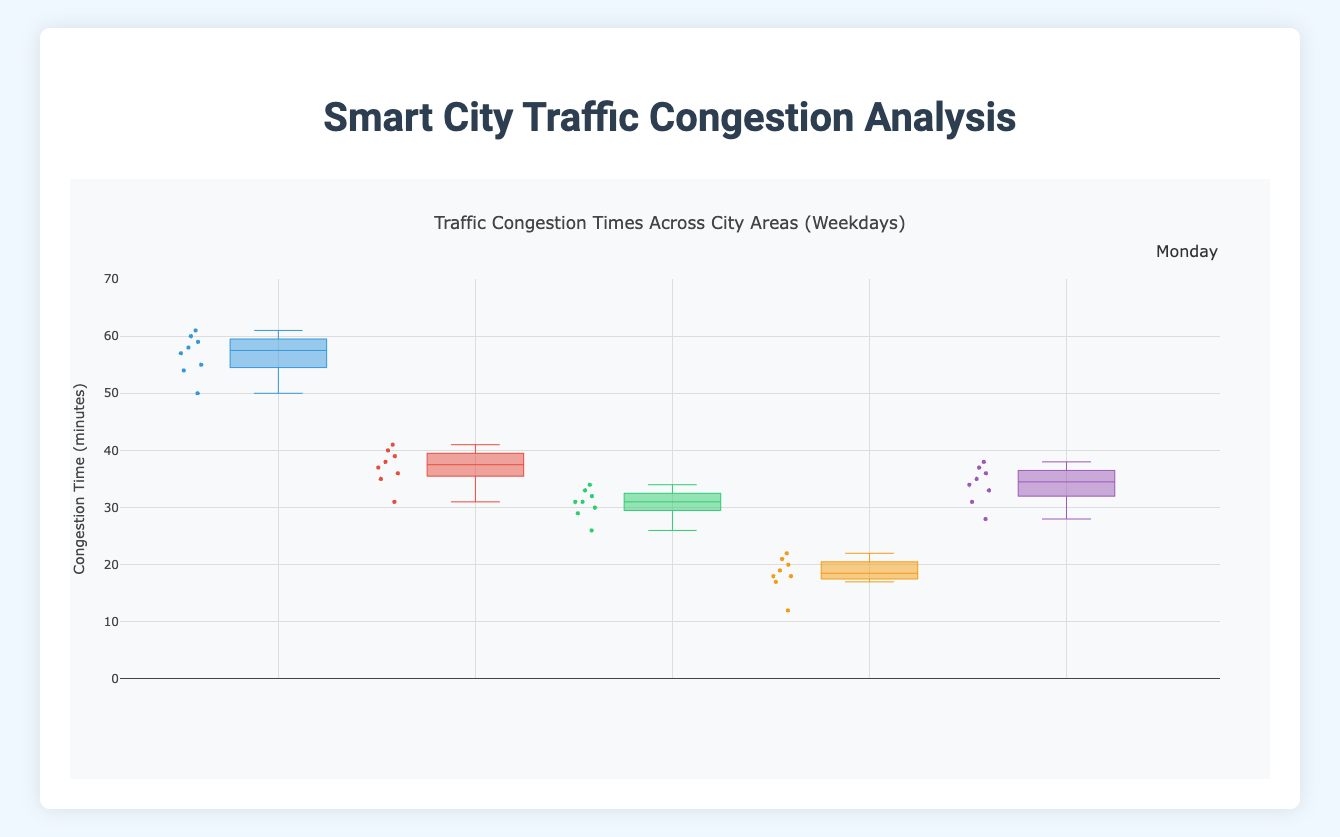What's the title of the figure? The title of the figure is typically placed at the top and provides a summary of the figure's content. In this case, it is "Traffic Congestion Times Across City Areas (Weekdays)."
Answer: Traffic Congestion Times Across City Areas (Weekdays) Which city area has the highest median congestion time on Monday? To find the highest median congestion time, look at the central line inside the boxes for each area on Monday. The area with the highest median value is Downtown.
Answer: Downtown How does the congestion time on Tuesdays in Uptown compare to Midtown? Compare the entire boxes representing congestion times for Uptown and Midtown on Tuesday. Uptown generally has lower congestion times compared to Midtown, as visible from the lower range of values.
Answer: Uptown is generally lower What is the range of congestion times for Suburbs on Monday? The range is the difference between the maximum and minimum values. For Suburbs on Monday, the maximum is around 20 minutes and the minimum is around 10 minutes, so the range is 20 - 10 = 10 minutes.
Answer: 10 minutes On which day does the Industrial Zone experience the highest congestion time, and what is the time? To determine the highest congestion time, check the upper whiskers across all weekdays for the Industrial Zone. The highest value is on Friday, which goes up to 38 minutes.
Answer: Friday, 38 minutes How does the congestion time variability (IQR) in Downtown on Wednesday compare to Uptown on Wednesday? To compare Interquartile Range (IQR), check the boxes' height (difference between the 75th percentile and 25th percentile). Downtown has a smaller box height compared to Uptown on Wednesday, meaning less variability.
Answer: Downtown has less variability Which day sees the least congestion in Midtown? Look for the smallest median value within the boxes from Monday to Friday for Midtown. Tuesday has the lowest median congestion value.
Answer: Tuesday Compare the median congestion times for Suburbs and Industrial Zone on Friday. Which is higher? Compare the central lines within the boxes for Suburbs and Industrial Zone on Friday. The Industrial Zone has a higher median congestion time compared to Suburbs.
Answer: Industrial Zone is higher Which city area generally experiences the least traffic congestion throughout the weekdays? Observing all boxes for all weekdays, Suburbs consistently show lower values compared to other city areas.
Answer: Suburbs What can be inferred about the consistency of congestion in Uptown on Thursdays compared to other days? Consistency can be assessed by the size of the boxes and whiskers. For Uptown, the box and whiskers on Thursday are neither the largest nor the smallest, suggesting moderate variability compared to other days.
Answer: Moderate variability 